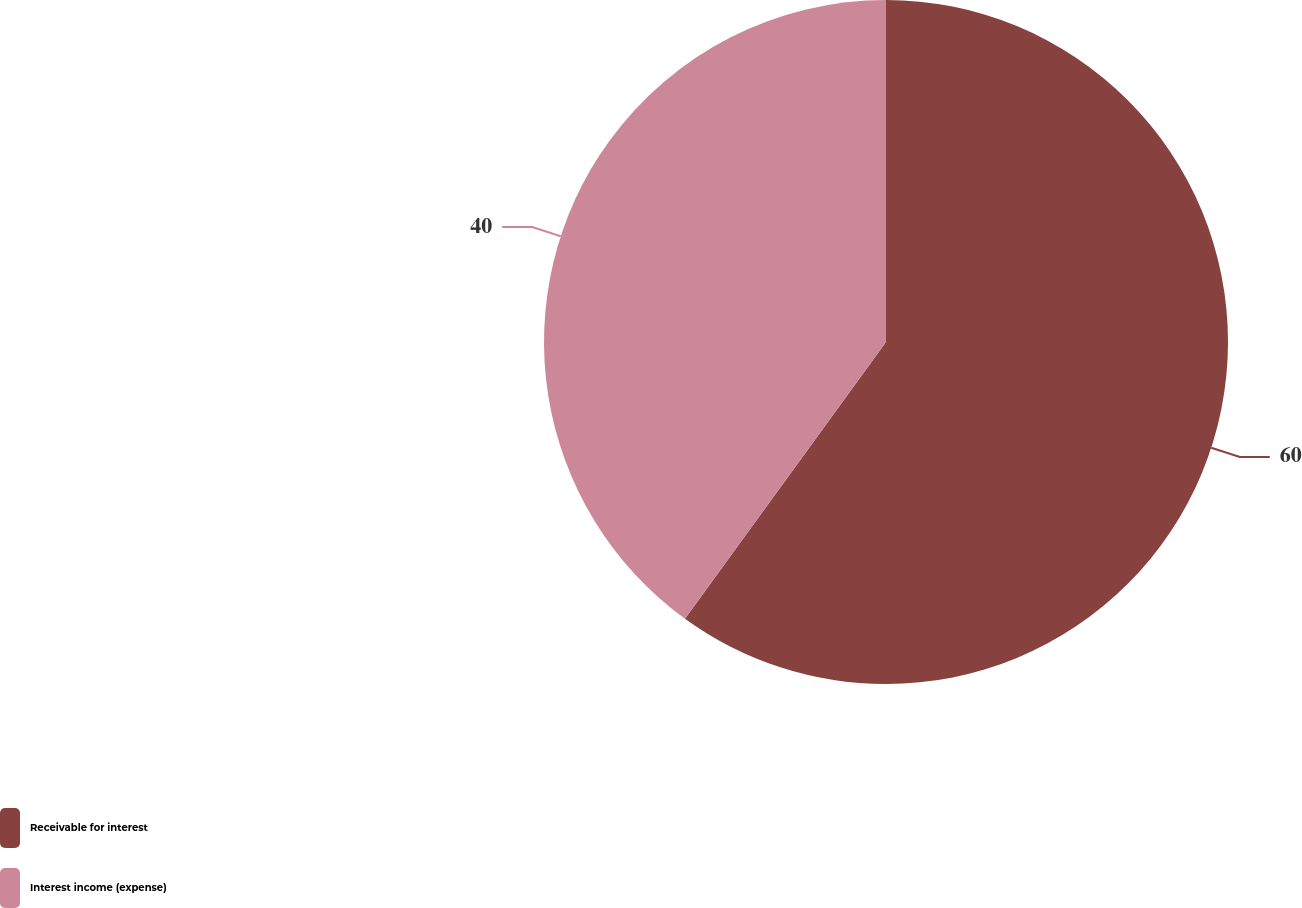Convert chart. <chart><loc_0><loc_0><loc_500><loc_500><pie_chart><fcel>Receivable for interest<fcel>Interest income (expense)<nl><fcel>60.0%<fcel>40.0%<nl></chart> 